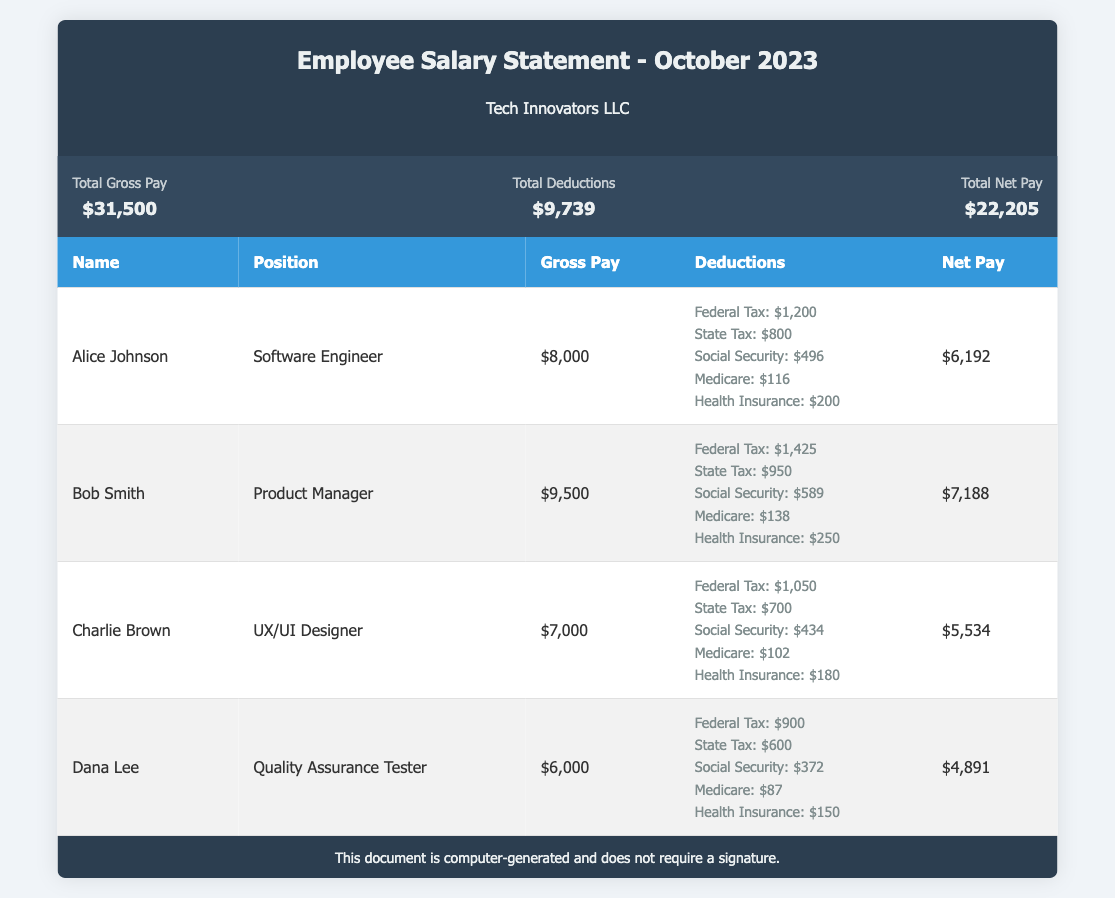What is the total gross pay? The total gross pay is the sum of all employees' gross pay, which is $8,000 + $9,500 + $7,000 + $6,000 = $31,500.
Answer: $31,500 What is Dana Lee's position? Dana Lee's position is listed directly in the document under the "Position" column.
Answer: Quality Assurance Tester What are the total deductions? The total deductions are calculated from the individual deductions of all employees, which sum up to $9,739.
Answer: $9,739 What is Alice Johnson's net pay? Alice Johnson's net pay is provided directly in the net pay column for her row in the table.
Answer: $6,192 How much is Bob Smith's federal tax deduction? Bob Smith's federal tax deduction is explicitly stated in the deductions section of his entry.
Answer: $1,425 How does Charlie Brown's gross pay compare to Dana Lee's? Charlie Brown's gross pay is $7,000 while Dana Lee's is $6,000, indicating Charlie earns more.
Answer: Higher What is the total net pay for all employees? The total net pay is provided in the document, reflecting the sum of all employees' net pay amounts.
Answer: $22,205 What is the highest gross pay among the employees listed? The highest gross pay is found in the gross pay column and is associated with Bob Smith.
Answer: $9,500 How many employees are listed in the salary statement? The number of employees can be counted from the entries in the table.
Answer: 4 